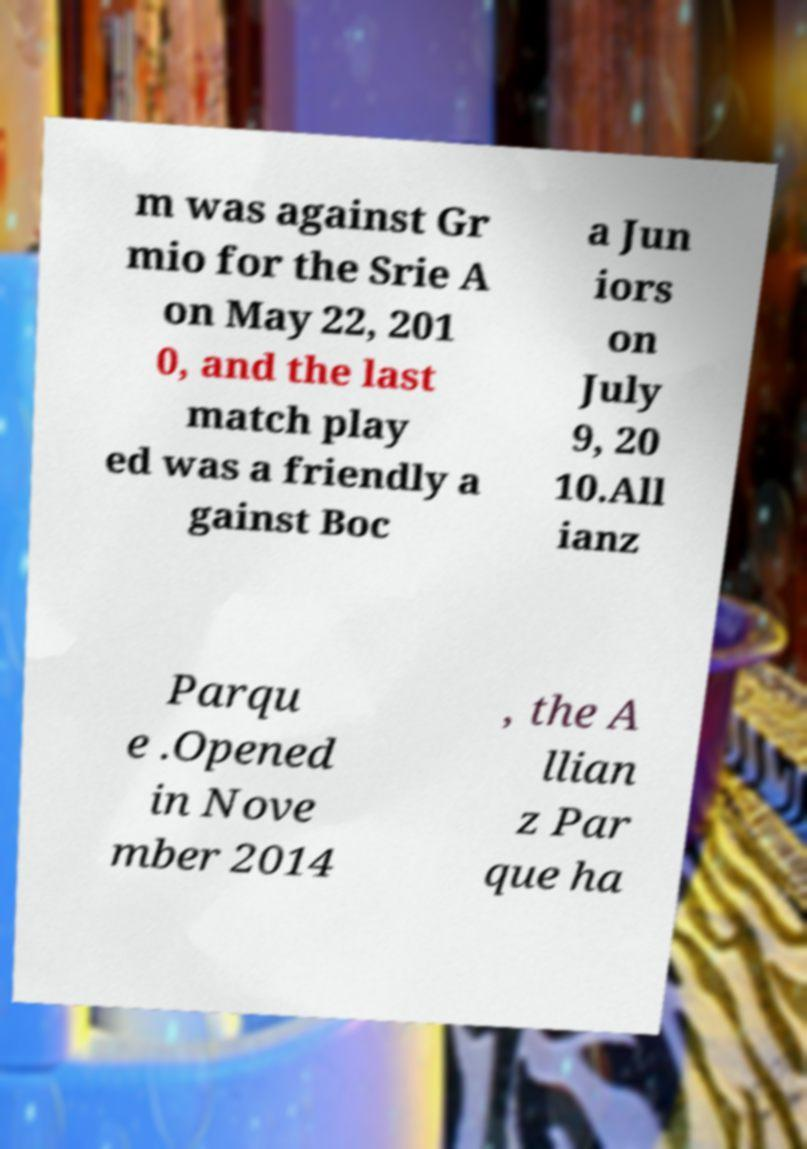Could you assist in decoding the text presented in this image and type it out clearly? m was against Gr mio for the Srie A on May 22, 201 0, and the last match play ed was a friendly a gainst Boc a Jun iors on July 9, 20 10.All ianz Parqu e .Opened in Nove mber 2014 , the A llian z Par que ha 